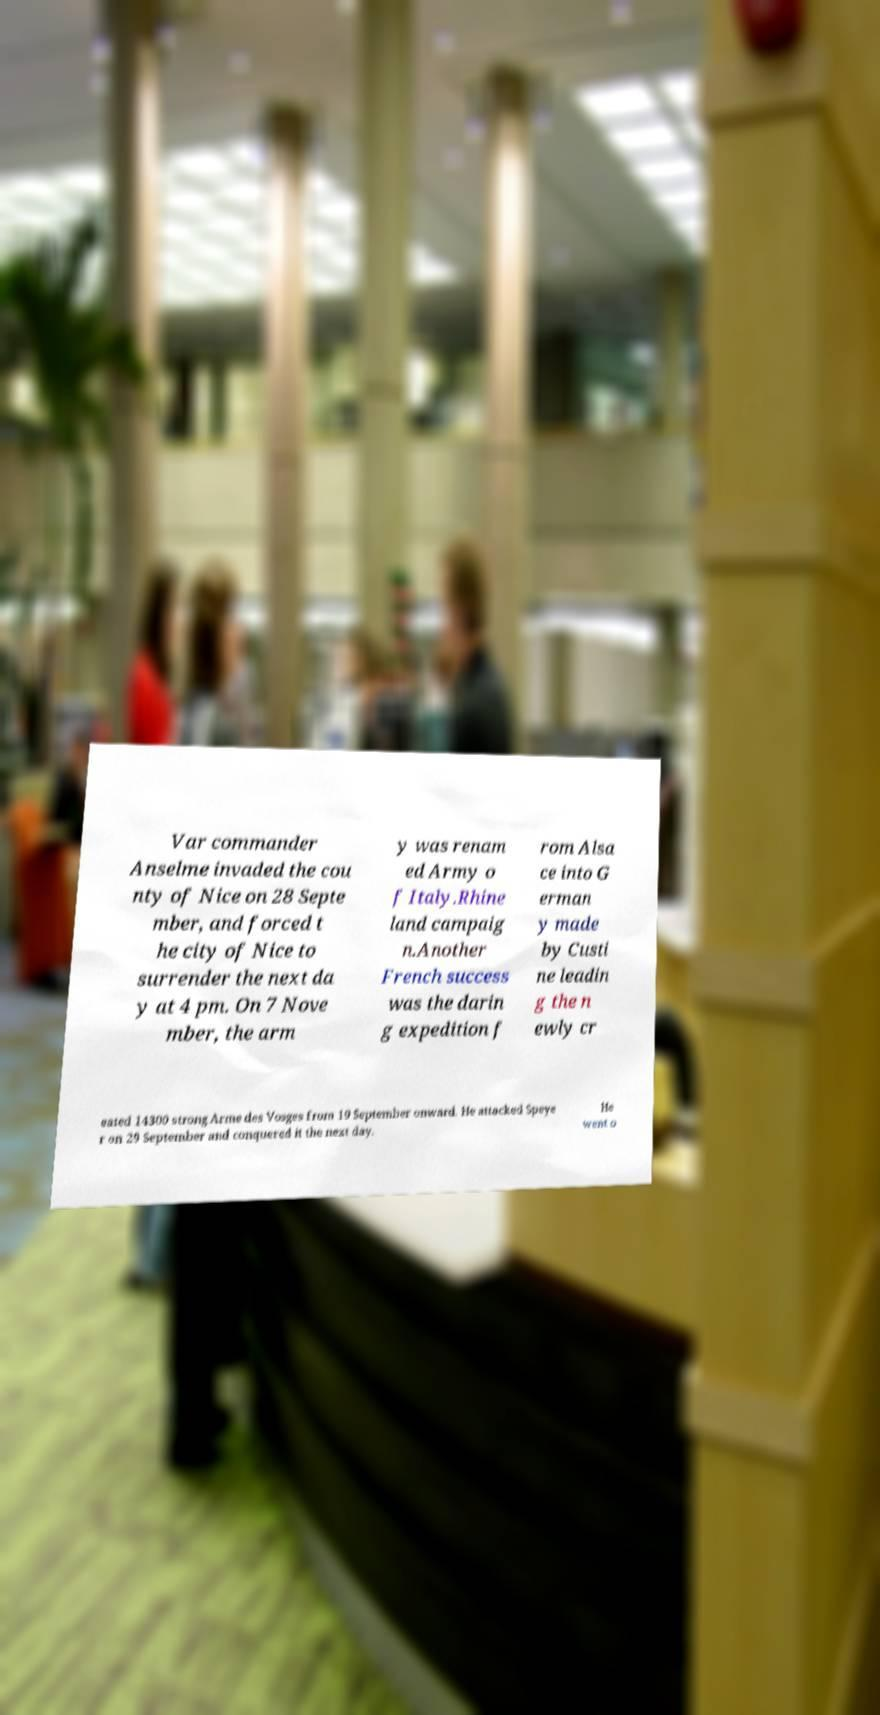Could you assist in decoding the text presented in this image and type it out clearly? Var commander Anselme invaded the cou nty of Nice on 28 Septe mber, and forced t he city of Nice to surrender the next da y at 4 pm. On 7 Nove mber, the arm y was renam ed Army o f Italy.Rhine land campaig n.Another French success was the darin g expedition f rom Alsa ce into G erman y made by Custi ne leadin g the n ewly cr eated 14300 strong Arme des Vosges from 19 September onward. He attacked Speye r on 29 September and conquered it the next day. He went o 